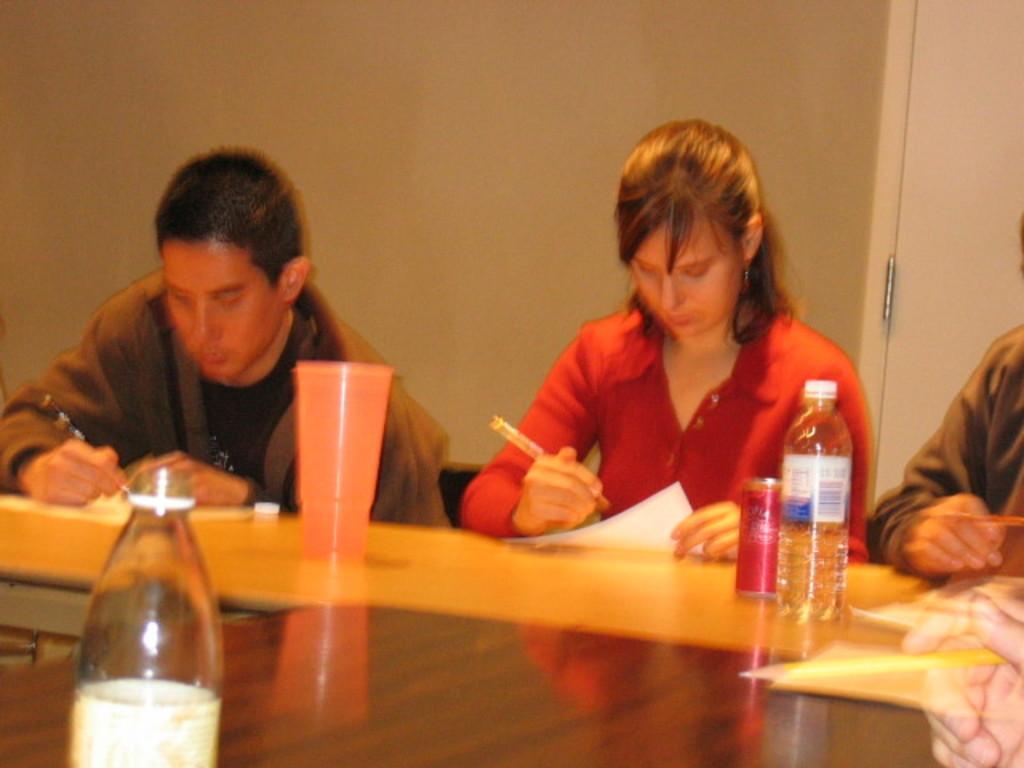Describe this image in one or two sentences. As we can see in the image there is are few people sitting on chairs and there is a table. On table there are bottles and glass. 